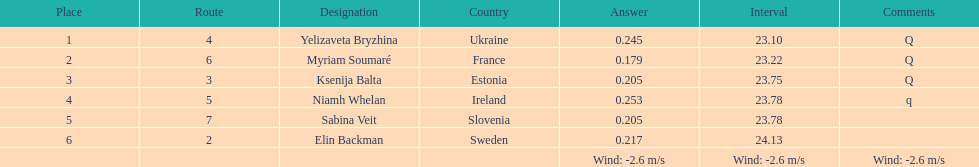The difference between yelizaveta bryzhina's time and ksenija balta's time? 0.65. 